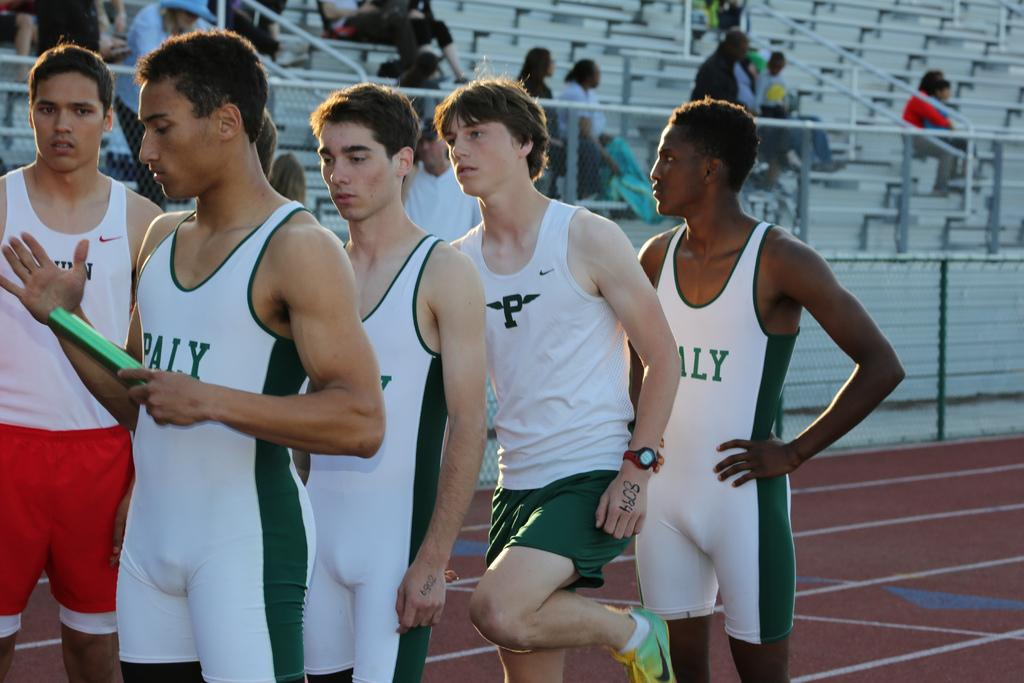Provide a one-sentence caption for the provided image. Runners are in line on a track and have the letter p om their uniforms. 